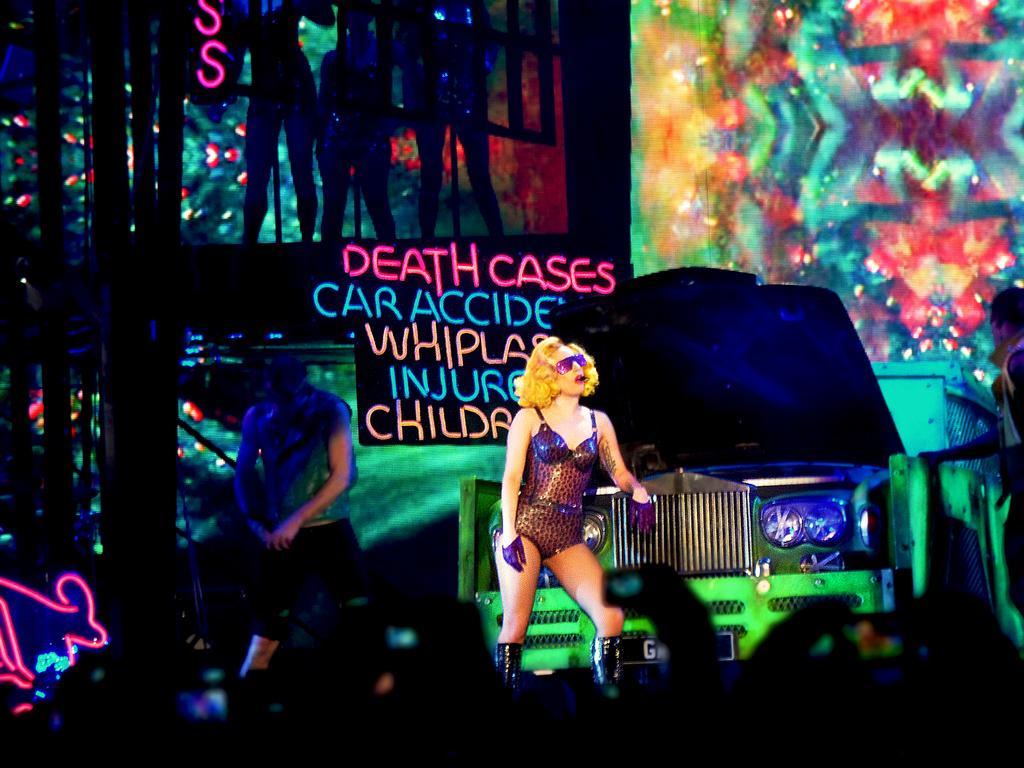Describe this image in one or two sentences. As we can see in the image there are few people here and there. The people in the front are holding cameras in their hands. There is a car and banners. 